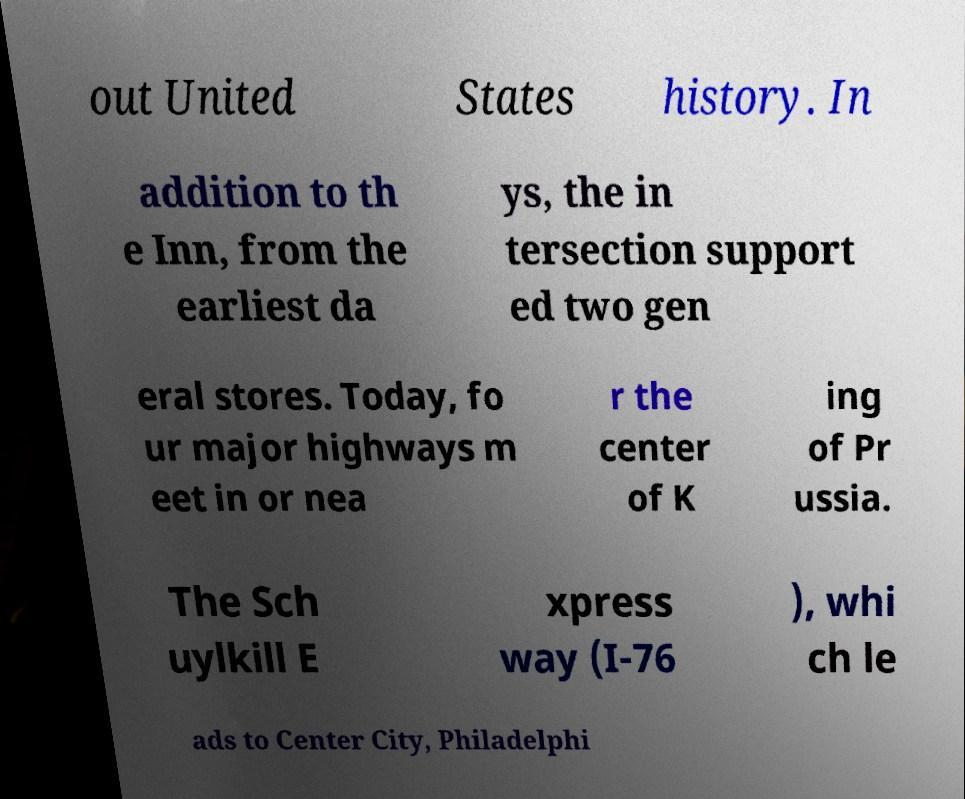Could you extract and type out the text from this image? out United States history. In addition to th e Inn, from the earliest da ys, the in tersection support ed two gen eral stores. Today, fo ur major highways m eet in or nea r the center of K ing of Pr ussia. The Sch uylkill E xpress way (I-76 ), whi ch le ads to Center City, Philadelphi 